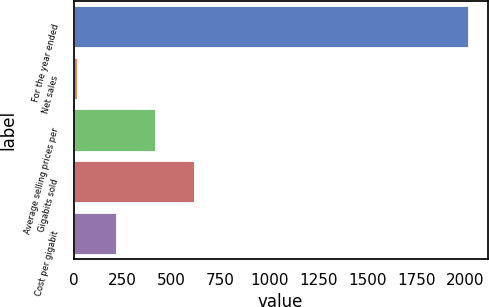<chart> <loc_0><loc_0><loc_500><loc_500><bar_chart><fcel>For the year ended<fcel>Net sales<fcel>Average selling prices per<fcel>Gigabits sold<fcel>Cost per gigabit<nl><fcel>2012<fcel>19<fcel>417.6<fcel>616.9<fcel>218.3<nl></chart> 